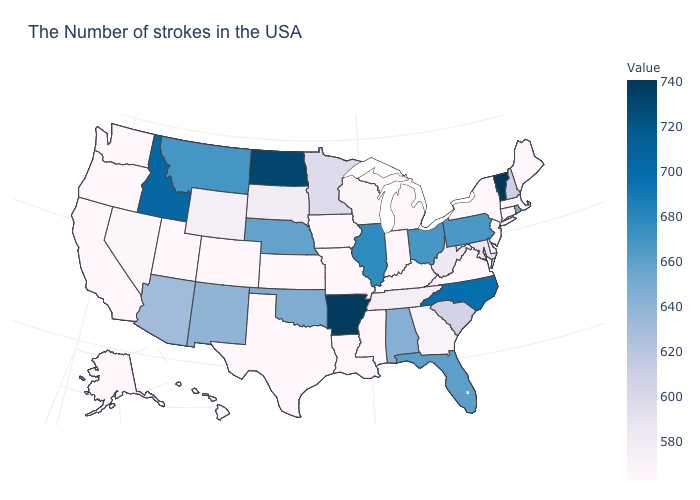Among the states that border Virginia , does North Carolina have the highest value?
Quick response, please. Yes. Does Iowa have the lowest value in the MidWest?
Be succinct. Yes. Does Oregon have the highest value in the West?
Quick response, please. No. Among the states that border Nebraska , does South Dakota have the highest value?
Answer briefly. Yes. 